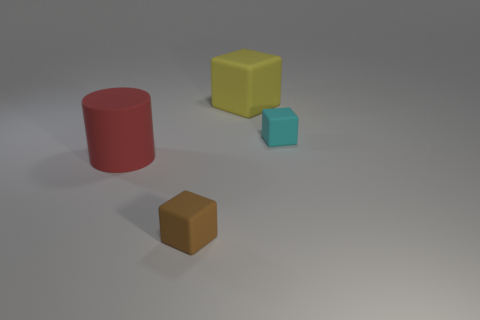How many small matte objects are the same color as the cylinder?
Offer a very short reply. 0. What number of things are either matte objects that are behind the large red object or tiny brown blocks?
Provide a short and direct response. 3. There is a big cylinder that is the same material as the big yellow cube; what is its color?
Provide a succinct answer. Red. Are there any things of the same size as the yellow rubber block?
Offer a terse response. Yes. What number of things are either blocks on the left side of the big yellow block or tiny things in front of the big matte cylinder?
Offer a terse response. 1. What is the shape of the yellow thing that is the same size as the red cylinder?
Provide a short and direct response. Cube. Is there a large yellow object of the same shape as the small cyan thing?
Keep it short and to the point. Yes. Is the number of objects less than the number of blue rubber things?
Keep it short and to the point. No. There is a rubber block in front of the large red rubber thing; is its size the same as the matte cube that is behind the cyan rubber thing?
Keep it short and to the point. No. What number of objects are either shiny spheres or tiny brown matte objects?
Provide a succinct answer. 1. 